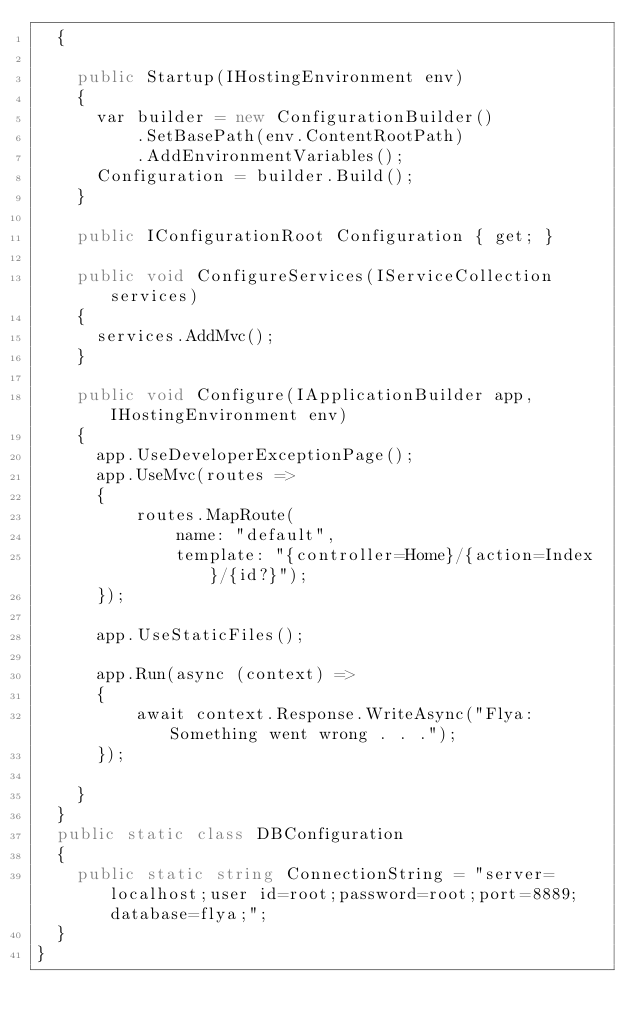<code> <loc_0><loc_0><loc_500><loc_500><_C#_>  {

    public Startup(IHostingEnvironment env)
    {
      var builder = new ConfigurationBuilder()
          .SetBasePath(env.ContentRootPath)
          .AddEnvironmentVariables();
      Configuration = builder.Build();
    }

    public IConfigurationRoot Configuration { get; }

    public void ConfigureServices(IServiceCollection services)
    {
      services.AddMvc();
    }

    public void Configure(IApplicationBuilder app, IHostingEnvironment env)
    {
      app.UseDeveloperExceptionPage();
      app.UseMvc(routes =>
      {
          routes.MapRoute(
              name: "default",
              template: "{controller=Home}/{action=Index}/{id?}");
      });

      app.UseStaticFiles();

      app.Run(async (context) =>
      {
          await context.Response.WriteAsync("Flya: Something went wrong . . .");
      });

    }
  }
  public static class DBConfiguration
  {
    public static string ConnectionString = "server=localhost;user id=root;password=root;port=8889;database=flya;";
  }
}
</code> 